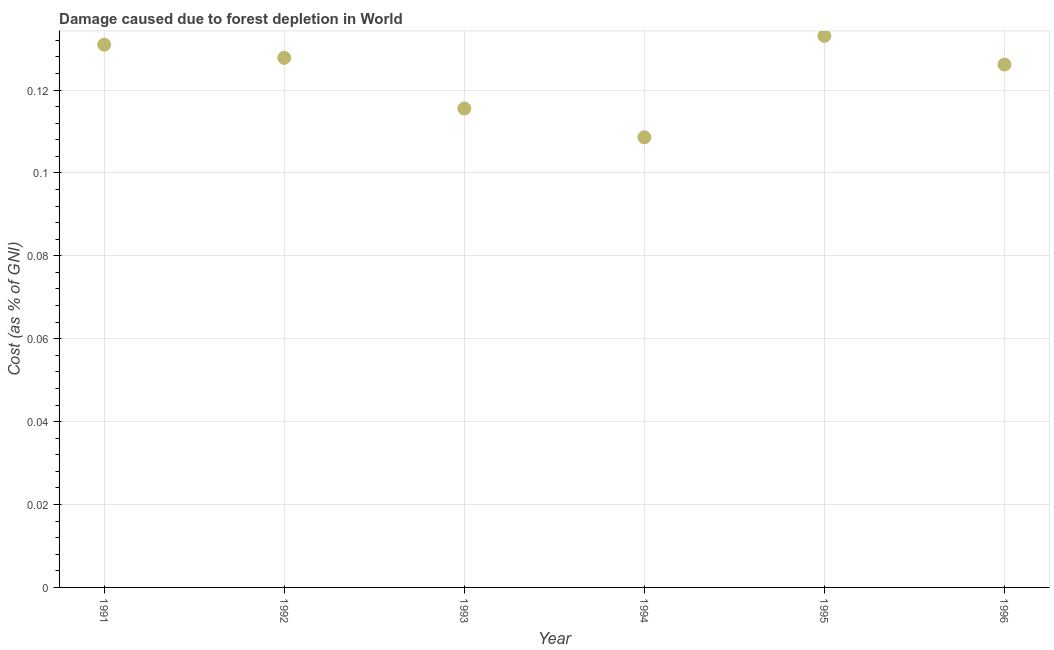What is the damage caused due to forest depletion in 1995?
Keep it short and to the point. 0.13. Across all years, what is the maximum damage caused due to forest depletion?
Provide a succinct answer. 0.13. Across all years, what is the minimum damage caused due to forest depletion?
Ensure brevity in your answer.  0.11. In which year was the damage caused due to forest depletion maximum?
Offer a terse response. 1995. In which year was the damage caused due to forest depletion minimum?
Offer a very short reply. 1994. What is the sum of the damage caused due to forest depletion?
Make the answer very short. 0.74. What is the difference between the damage caused due to forest depletion in 1994 and 1996?
Keep it short and to the point. -0.02. What is the average damage caused due to forest depletion per year?
Offer a terse response. 0.12. What is the median damage caused due to forest depletion?
Your answer should be very brief. 0.13. In how many years, is the damage caused due to forest depletion greater than 0.084 %?
Offer a terse response. 6. Do a majority of the years between 1992 and 1991 (inclusive) have damage caused due to forest depletion greater than 0.012 %?
Ensure brevity in your answer.  No. What is the ratio of the damage caused due to forest depletion in 1991 to that in 1993?
Offer a terse response. 1.13. What is the difference between the highest and the second highest damage caused due to forest depletion?
Your response must be concise. 0. What is the difference between the highest and the lowest damage caused due to forest depletion?
Offer a very short reply. 0.02. In how many years, is the damage caused due to forest depletion greater than the average damage caused due to forest depletion taken over all years?
Your answer should be compact. 4. Does the damage caused due to forest depletion monotonically increase over the years?
Provide a short and direct response. No. How many dotlines are there?
Offer a very short reply. 1. How many years are there in the graph?
Provide a succinct answer. 6. What is the difference between two consecutive major ticks on the Y-axis?
Provide a succinct answer. 0.02. Are the values on the major ticks of Y-axis written in scientific E-notation?
Provide a succinct answer. No. Does the graph contain any zero values?
Your answer should be very brief. No. What is the title of the graph?
Provide a short and direct response. Damage caused due to forest depletion in World. What is the label or title of the X-axis?
Give a very brief answer. Year. What is the label or title of the Y-axis?
Provide a short and direct response. Cost (as % of GNI). What is the Cost (as % of GNI) in 1991?
Your response must be concise. 0.13. What is the Cost (as % of GNI) in 1992?
Ensure brevity in your answer.  0.13. What is the Cost (as % of GNI) in 1993?
Give a very brief answer. 0.12. What is the Cost (as % of GNI) in 1994?
Make the answer very short. 0.11. What is the Cost (as % of GNI) in 1995?
Keep it short and to the point. 0.13. What is the Cost (as % of GNI) in 1996?
Provide a succinct answer. 0.13. What is the difference between the Cost (as % of GNI) in 1991 and 1992?
Your answer should be very brief. 0. What is the difference between the Cost (as % of GNI) in 1991 and 1993?
Make the answer very short. 0.02. What is the difference between the Cost (as % of GNI) in 1991 and 1994?
Your answer should be compact. 0.02. What is the difference between the Cost (as % of GNI) in 1991 and 1995?
Keep it short and to the point. -0. What is the difference between the Cost (as % of GNI) in 1991 and 1996?
Keep it short and to the point. 0. What is the difference between the Cost (as % of GNI) in 1992 and 1993?
Provide a succinct answer. 0.01. What is the difference between the Cost (as % of GNI) in 1992 and 1994?
Your answer should be very brief. 0.02. What is the difference between the Cost (as % of GNI) in 1992 and 1995?
Ensure brevity in your answer.  -0.01. What is the difference between the Cost (as % of GNI) in 1992 and 1996?
Provide a succinct answer. 0. What is the difference between the Cost (as % of GNI) in 1993 and 1994?
Give a very brief answer. 0.01. What is the difference between the Cost (as % of GNI) in 1993 and 1995?
Offer a very short reply. -0.02. What is the difference between the Cost (as % of GNI) in 1993 and 1996?
Provide a short and direct response. -0.01. What is the difference between the Cost (as % of GNI) in 1994 and 1995?
Provide a short and direct response. -0.02. What is the difference between the Cost (as % of GNI) in 1994 and 1996?
Offer a terse response. -0.02. What is the difference between the Cost (as % of GNI) in 1995 and 1996?
Give a very brief answer. 0.01. What is the ratio of the Cost (as % of GNI) in 1991 to that in 1993?
Provide a short and direct response. 1.13. What is the ratio of the Cost (as % of GNI) in 1991 to that in 1994?
Your answer should be very brief. 1.21. What is the ratio of the Cost (as % of GNI) in 1991 to that in 1995?
Offer a very short reply. 0.98. What is the ratio of the Cost (as % of GNI) in 1991 to that in 1996?
Offer a very short reply. 1.04. What is the ratio of the Cost (as % of GNI) in 1992 to that in 1993?
Your answer should be compact. 1.11. What is the ratio of the Cost (as % of GNI) in 1992 to that in 1994?
Ensure brevity in your answer.  1.18. What is the ratio of the Cost (as % of GNI) in 1992 to that in 1995?
Your response must be concise. 0.96. What is the ratio of the Cost (as % of GNI) in 1992 to that in 1996?
Your response must be concise. 1.01. What is the ratio of the Cost (as % of GNI) in 1993 to that in 1994?
Offer a terse response. 1.06. What is the ratio of the Cost (as % of GNI) in 1993 to that in 1995?
Offer a very short reply. 0.87. What is the ratio of the Cost (as % of GNI) in 1993 to that in 1996?
Make the answer very short. 0.92. What is the ratio of the Cost (as % of GNI) in 1994 to that in 1995?
Give a very brief answer. 0.82. What is the ratio of the Cost (as % of GNI) in 1994 to that in 1996?
Provide a short and direct response. 0.86. What is the ratio of the Cost (as % of GNI) in 1995 to that in 1996?
Offer a terse response. 1.05. 